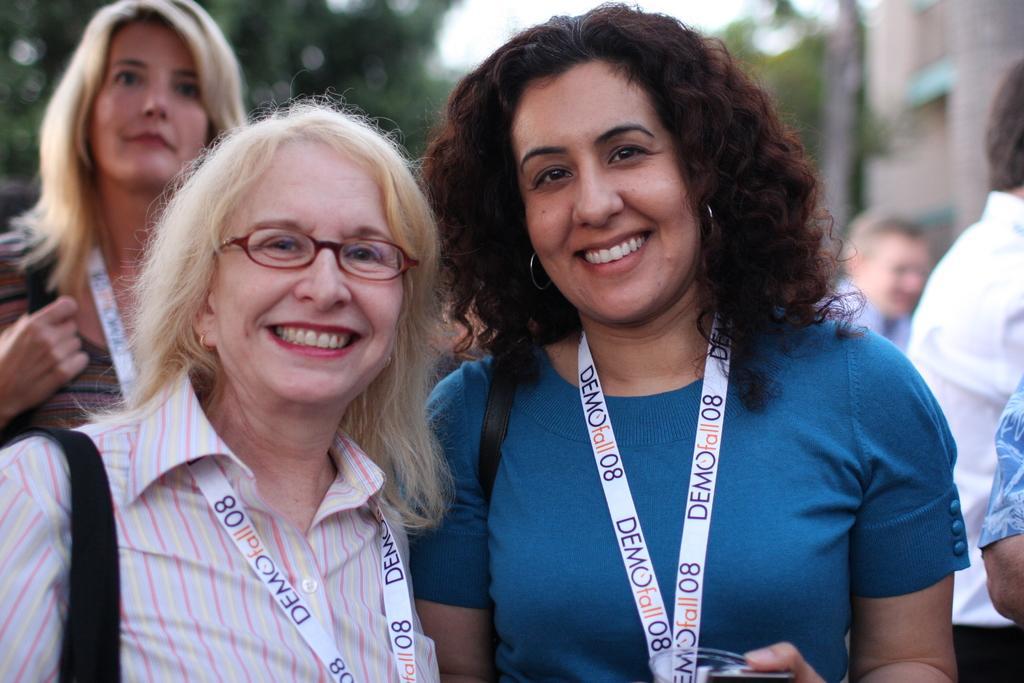Could you give a brief overview of what you see in this image? At the left side of the image there is a lady with pink shirt is smiling and around her neck there is a tag. Behind her there is another lady standing. Beside the pink shirt lady there is a lady with blue t-shirt is standing and there is a tag around her neck. To the right side of the image there are few people standing. In the background there is a green color. 